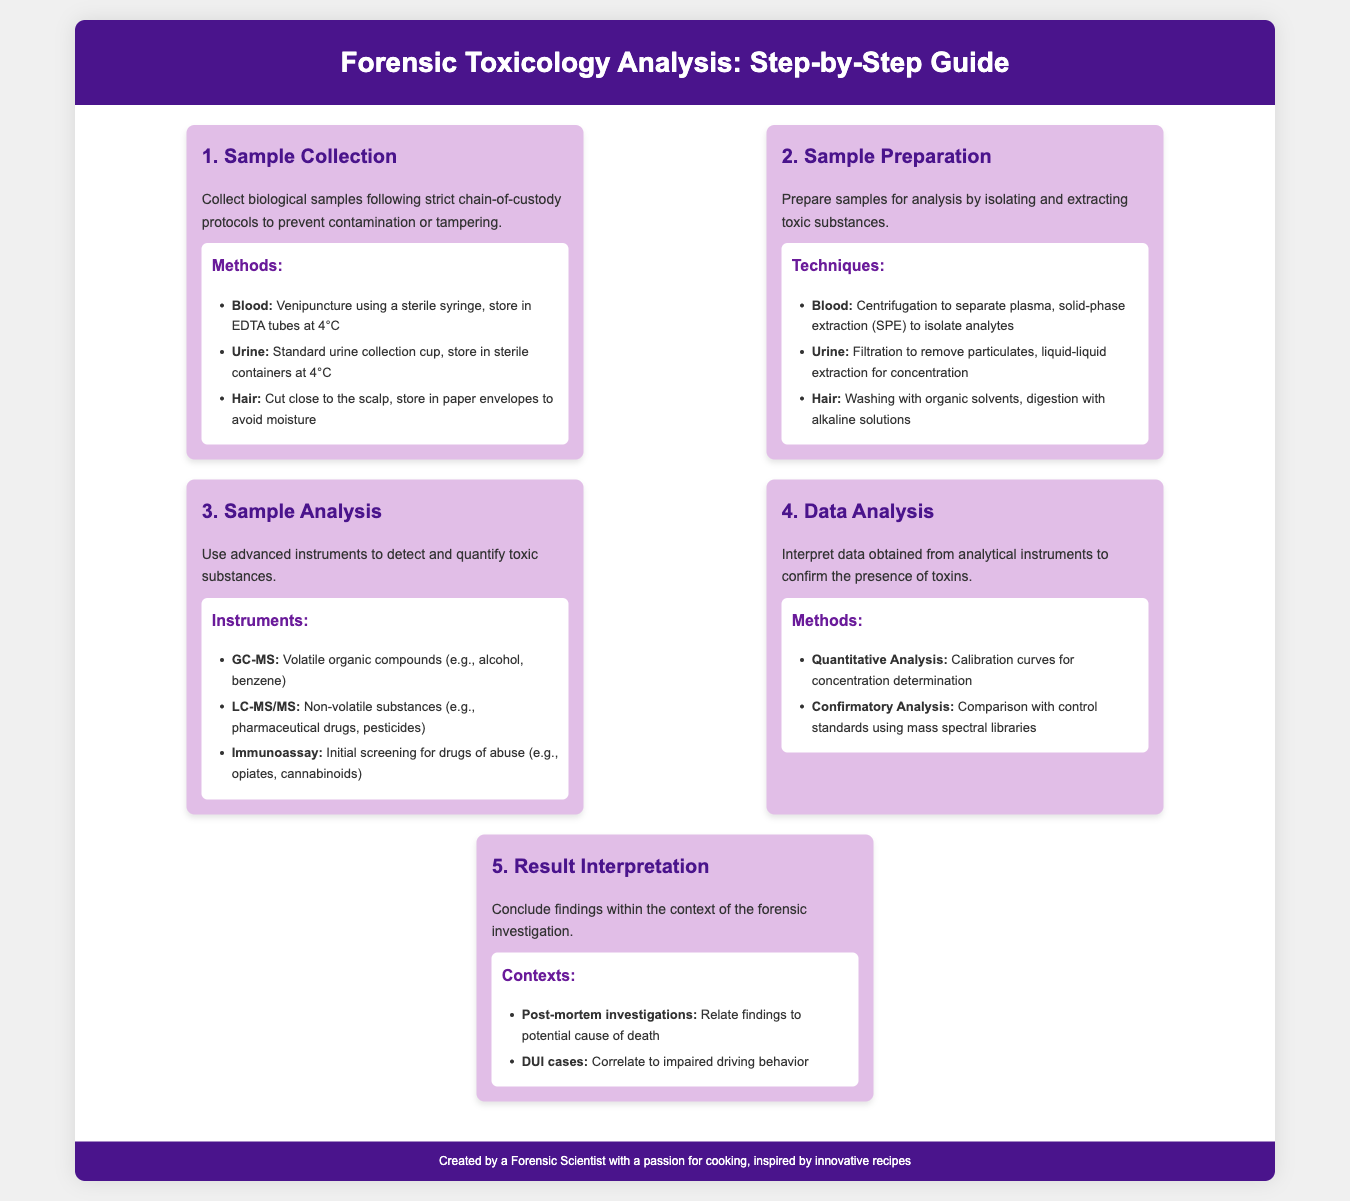What is the first step in forensic toxicology analysis? The first step in the forensic toxicology analysis process is sample collection, as indicated in the initial section of the infographic.
Answer: Sample Collection What must be followed during sample collection? The document states that strict chain-of-custody protocols must be followed to ensure the integrity of the samples.
Answer: Chain-of-custody protocols Which instrument is used to detect volatile organic compounds? The document identifies GC-MS as the instrument used for detecting volatile organic compounds.
Answer: GC-MS What type of analysis confirms the presence of toxins? Confirmatory analysis is mentioned as a method used to confirm the presence of toxins based on comparisons with control standards.
Answer: Confirmatory analysis How many techniques are mentioned for sample preparation? There are three techniques outlined for sample preparation in the infographic.
Answer: Three techniques What does the result interpretation relate to in post-mortem investigations? The document states that result interpretation in post-mortem investigations relates findings to the potential cause of death.
Answer: Potential cause of death What is the total number of steps in the forensic toxicology analysis process? There are five steps detailed in the infographic concerning the forensic toxicology analysis process.
Answer: Five steps Which biological sample is cut close to the scalp? The document specifies that hair samples are cut close to the scalp for collection in the analysis process.
Answer: Hair What must happen to urine samples before analysis? Urine samples must undergo filtration to remove particulates as a part of their preparation for analysis.
Answer: Filtration 